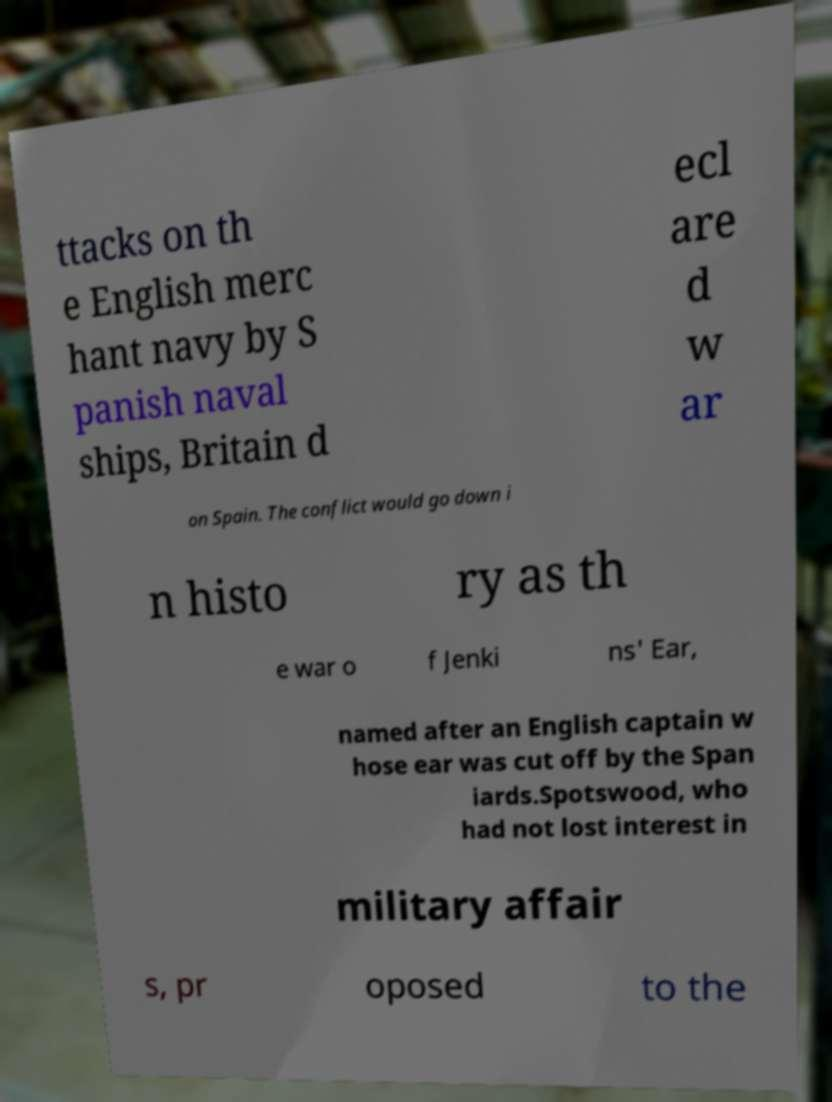I need the written content from this picture converted into text. Can you do that? ttacks on th e English merc hant navy by S panish naval ships, Britain d ecl are d w ar on Spain. The conflict would go down i n histo ry as th e war o f Jenki ns' Ear, named after an English captain w hose ear was cut off by the Span iards.Spotswood, who had not lost interest in military affair s, pr oposed to the 